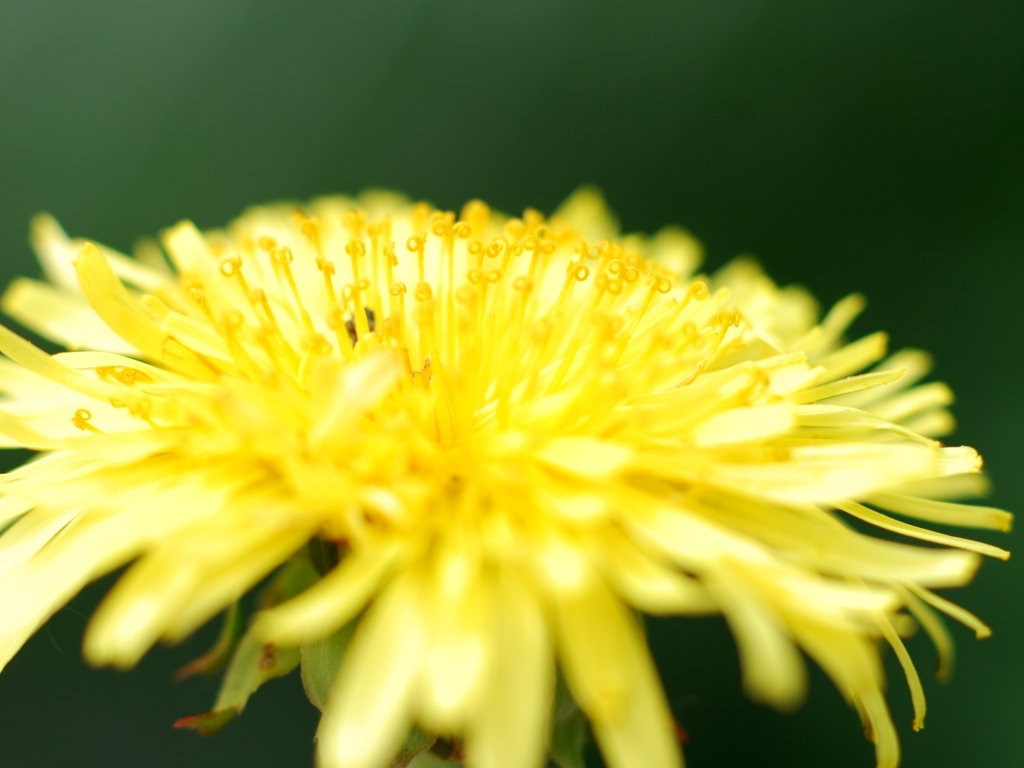Can you describe the mood or atmosphere that the image evokes? Certainly! The image evokes a serene and tranquil atmosphere. The soft focus on the dandelion and the blurred green background suggest a peaceful setting, perhaps a quiet spot in a meadow or garden. The natural simplicity of the single flower against the calm backdrop may inspire feelings of relaxation and contemplation. 